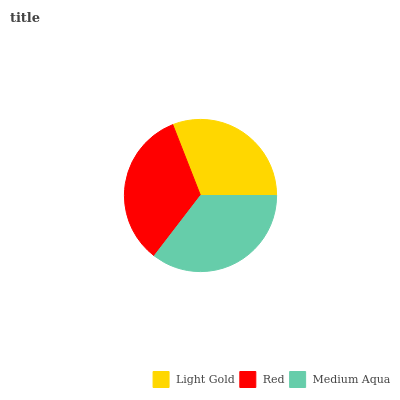Is Light Gold the minimum?
Answer yes or no. Yes. Is Medium Aqua the maximum?
Answer yes or no. Yes. Is Red the minimum?
Answer yes or no. No. Is Red the maximum?
Answer yes or no. No. Is Red greater than Light Gold?
Answer yes or no. Yes. Is Light Gold less than Red?
Answer yes or no. Yes. Is Light Gold greater than Red?
Answer yes or no. No. Is Red less than Light Gold?
Answer yes or no. No. Is Red the high median?
Answer yes or no. Yes. Is Red the low median?
Answer yes or no. Yes. Is Light Gold the high median?
Answer yes or no. No. Is Light Gold the low median?
Answer yes or no. No. 